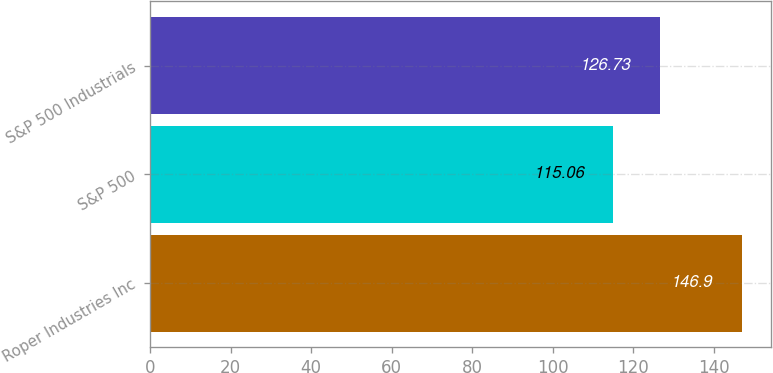Convert chart to OTSL. <chart><loc_0><loc_0><loc_500><loc_500><bar_chart><fcel>Roper Industries Inc<fcel>S&P 500<fcel>S&P 500 Industrials<nl><fcel>146.9<fcel>115.06<fcel>126.73<nl></chart> 